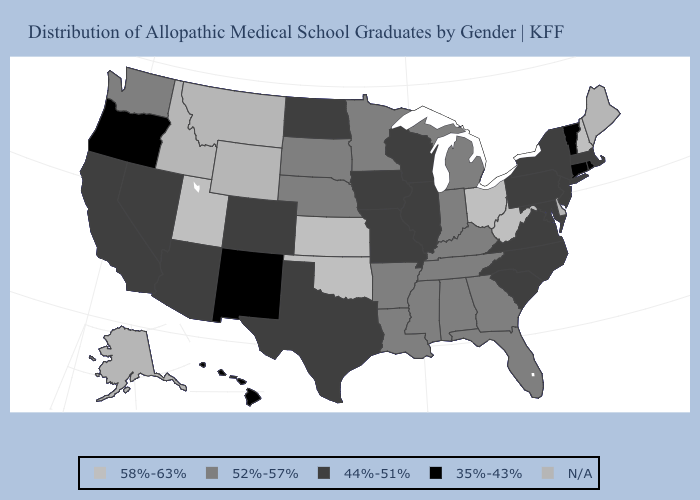What is the value of New Jersey?
Answer briefly. 44%-51%. Among the states that border Utah , which have the lowest value?
Be succinct. New Mexico. Which states have the lowest value in the USA?
Write a very short answer. Connecticut, Hawaii, New Mexico, Oregon, Rhode Island, Vermont. Among the states that border Ohio , does Michigan have the lowest value?
Keep it brief. No. Does Texas have the lowest value in the South?
Short answer required. Yes. What is the highest value in the MidWest ?
Be succinct. 58%-63%. What is the value of Montana?
Give a very brief answer. N/A. What is the value of Utah?
Keep it brief. 58%-63%. Among the states that border Wyoming , does South Dakota have the lowest value?
Quick response, please. No. What is the value of Missouri?
Keep it brief. 44%-51%. Name the states that have a value in the range 35%-43%?
Be succinct. Connecticut, Hawaii, New Mexico, Oregon, Rhode Island, Vermont. What is the lowest value in the USA?
Short answer required. 35%-43%. Among the states that border Louisiana , which have the highest value?
Quick response, please. Arkansas, Mississippi. Which states have the highest value in the USA?
Answer briefly. Kansas, New Hampshire, Ohio, Oklahoma, Utah, West Virginia. 